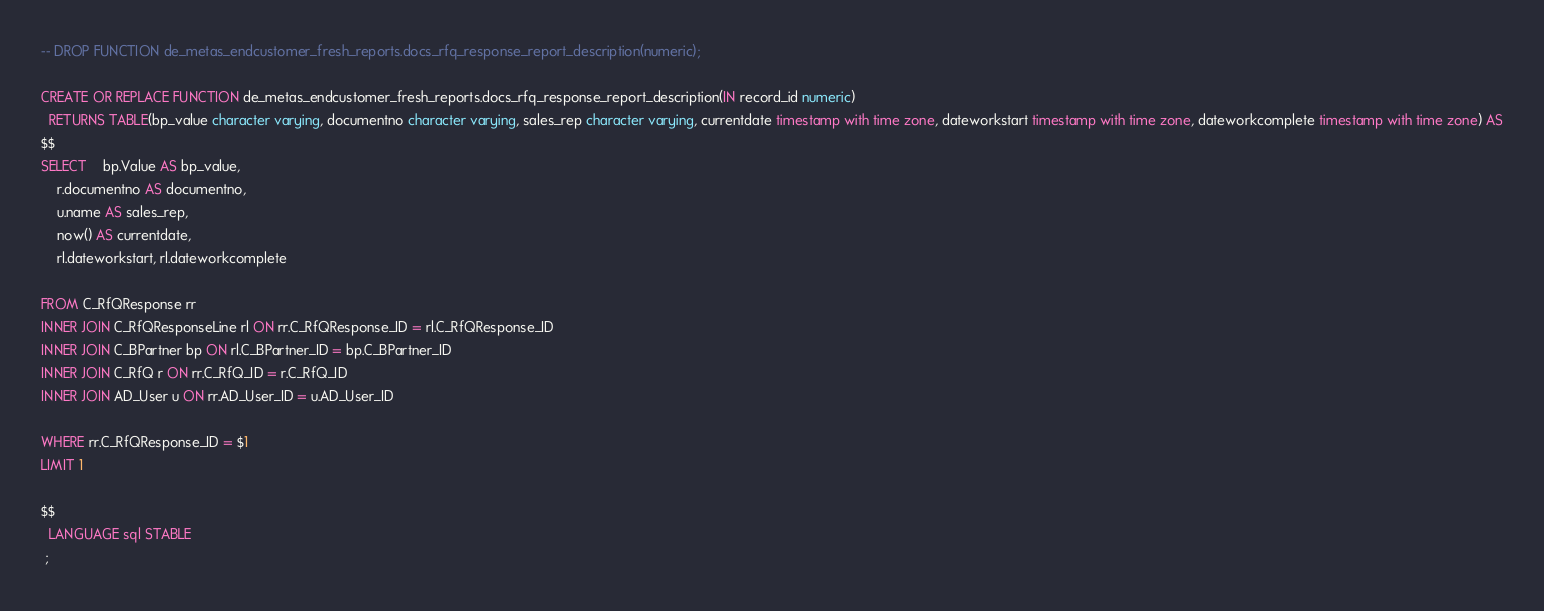<code> <loc_0><loc_0><loc_500><loc_500><_SQL_>-- DROP FUNCTION de_metas_endcustomer_fresh_reports.docs_rfq_response_report_description(numeric);

CREATE OR REPLACE FUNCTION de_metas_endcustomer_fresh_reports.docs_rfq_response_report_description(IN record_id numeric)
  RETURNS TABLE(bp_value character varying, documentno character varying, sales_rep character varying, currentdate timestamp with time zone, dateworkstart timestamp with time zone, dateworkcomplete timestamp with time zone) AS
$$
SELECT	bp.Value AS bp_value, 
	r.documentno AS documentno, 
	u.name AS sales_rep, 
	now() AS currentdate,
	rl.dateworkstart, rl.dateworkcomplete

FROM C_RfQResponse rr
INNER JOIN C_RfQResponseLine rl ON rr.C_RfQResponse_ID = rl.C_RfQResponse_ID
INNER JOIN C_BPartner bp ON rl.C_BPartner_ID = bp.C_BPartner_ID
INNER JOIN C_RfQ r ON rr.C_RfQ_ID = r.C_RfQ_ID
INNER JOIN AD_User u ON rr.AD_User_ID = u.AD_User_ID

WHERE rr.C_RfQResponse_ID = $1
LIMIT 1

$$
  LANGUAGE sql STABLE
 ;
</code> 